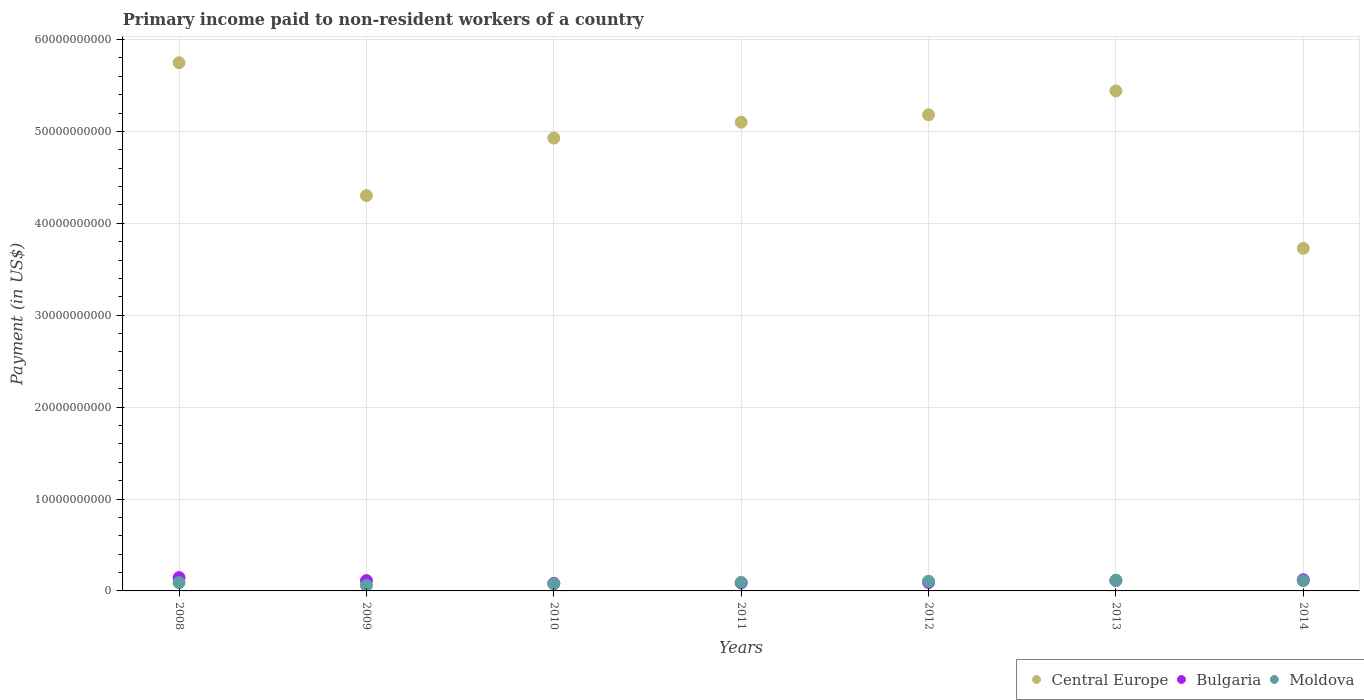How many different coloured dotlines are there?
Your answer should be compact. 3. What is the amount paid to workers in Moldova in 2010?
Offer a very short reply. 7.67e+08. Across all years, what is the maximum amount paid to workers in Moldova?
Your response must be concise. 1.16e+09. Across all years, what is the minimum amount paid to workers in Bulgaria?
Your answer should be very brief. 8.16e+08. In which year was the amount paid to workers in Bulgaria maximum?
Ensure brevity in your answer.  2008. What is the total amount paid to workers in Central Europe in the graph?
Your answer should be very brief. 3.44e+11. What is the difference between the amount paid to workers in Bulgaria in 2011 and that in 2013?
Make the answer very short. -2.82e+08. What is the difference between the amount paid to workers in Central Europe in 2013 and the amount paid to workers in Bulgaria in 2014?
Ensure brevity in your answer.  5.32e+1. What is the average amount paid to workers in Moldova per year?
Offer a terse response. 9.31e+08. In the year 2009, what is the difference between the amount paid to workers in Moldova and amount paid to workers in Central Europe?
Give a very brief answer. -4.24e+1. What is the ratio of the amount paid to workers in Moldova in 2009 to that in 2014?
Your answer should be compact. 0.53. What is the difference between the highest and the second highest amount paid to workers in Moldova?
Your answer should be compact. 4.90e+07. What is the difference between the highest and the lowest amount paid to workers in Bulgaria?
Provide a short and direct response. 6.34e+08. In how many years, is the amount paid to workers in Central Europe greater than the average amount paid to workers in Central Europe taken over all years?
Give a very brief answer. 5. Is the sum of the amount paid to workers in Central Europe in 2009 and 2010 greater than the maximum amount paid to workers in Bulgaria across all years?
Give a very brief answer. Yes. Is it the case that in every year, the sum of the amount paid to workers in Bulgaria and amount paid to workers in Central Europe  is greater than the amount paid to workers in Moldova?
Provide a succinct answer. Yes. Does the amount paid to workers in Bulgaria monotonically increase over the years?
Your response must be concise. No. Is the amount paid to workers in Moldova strictly greater than the amount paid to workers in Central Europe over the years?
Provide a short and direct response. No. How many dotlines are there?
Make the answer very short. 3. What is the difference between two consecutive major ticks on the Y-axis?
Ensure brevity in your answer.  1.00e+1. Does the graph contain any zero values?
Make the answer very short. No. Where does the legend appear in the graph?
Keep it short and to the point. Bottom right. How many legend labels are there?
Provide a short and direct response. 3. What is the title of the graph?
Provide a short and direct response. Primary income paid to non-resident workers of a country. What is the label or title of the Y-axis?
Your answer should be compact. Payment (in US$). What is the Payment (in US$) of Central Europe in 2008?
Offer a terse response. 5.75e+1. What is the Payment (in US$) of Bulgaria in 2008?
Offer a very short reply. 1.45e+09. What is the Payment (in US$) in Moldova in 2008?
Ensure brevity in your answer.  9.06e+08. What is the Payment (in US$) of Central Europe in 2009?
Your answer should be very brief. 4.30e+1. What is the Payment (in US$) in Bulgaria in 2009?
Your response must be concise. 1.12e+09. What is the Payment (in US$) of Moldova in 2009?
Keep it short and to the point. 5.92e+08. What is the Payment (in US$) in Central Europe in 2010?
Keep it short and to the point. 4.93e+1. What is the Payment (in US$) of Bulgaria in 2010?
Your answer should be very brief. 8.16e+08. What is the Payment (in US$) of Moldova in 2010?
Offer a very short reply. 7.67e+08. What is the Payment (in US$) in Central Europe in 2011?
Your answer should be compact. 5.10e+1. What is the Payment (in US$) of Bulgaria in 2011?
Your answer should be very brief. 8.61e+08. What is the Payment (in US$) of Moldova in 2011?
Offer a very short reply. 9.27e+08. What is the Payment (in US$) in Central Europe in 2012?
Provide a short and direct response. 5.18e+1. What is the Payment (in US$) in Bulgaria in 2012?
Offer a very short reply. 9.18e+08. What is the Payment (in US$) in Moldova in 2012?
Make the answer very short. 1.05e+09. What is the Payment (in US$) of Central Europe in 2013?
Your response must be concise. 5.44e+1. What is the Payment (in US$) of Bulgaria in 2013?
Your response must be concise. 1.14e+09. What is the Payment (in US$) of Moldova in 2013?
Offer a terse response. 1.16e+09. What is the Payment (in US$) of Central Europe in 2014?
Your answer should be compact. 3.73e+1. What is the Payment (in US$) of Bulgaria in 2014?
Offer a very short reply. 1.22e+09. What is the Payment (in US$) in Moldova in 2014?
Keep it short and to the point. 1.11e+09. Across all years, what is the maximum Payment (in US$) in Central Europe?
Make the answer very short. 5.75e+1. Across all years, what is the maximum Payment (in US$) of Bulgaria?
Offer a very short reply. 1.45e+09. Across all years, what is the maximum Payment (in US$) of Moldova?
Keep it short and to the point. 1.16e+09. Across all years, what is the minimum Payment (in US$) in Central Europe?
Provide a short and direct response. 3.73e+1. Across all years, what is the minimum Payment (in US$) of Bulgaria?
Your response must be concise. 8.16e+08. Across all years, what is the minimum Payment (in US$) of Moldova?
Give a very brief answer. 5.92e+08. What is the total Payment (in US$) of Central Europe in the graph?
Provide a succinct answer. 3.44e+11. What is the total Payment (in US$) of Bulgaria in the graph?
Make the answer very short. 7.53e+09. What is the total Payment (in US$) of Moldova in the graph?
Give a very brief answer. 6.52e+09. What is the difference between the Payment (in US$) in Central Europe in 2008 and that in 2009?
Give a very brief answer. 1.45e+1. What is the difference between the Payment (in US$) of Bulgaria in 2008 and that in 2009?
Offer a very short reply. 3.31e+08. What is the difference between the Payment (in US$) in Moldova in 2008 and that in 2009?
Your response must be concise. 3.14e+08. What is the difference between the Payment (in US$) of Central Europe in 2008 and that in 2010?
Keep it short and to the point. 8.20e+09. What is the difference between the Payment (in US$) of Bulgaria in 2008 and that in 2010?
Provide a short and direct response. 6.34e+08. What is the difference between the Payment (in US$) of Moldova in 2008 and that in 2010?
Your response must be concise. 1.39e+08. What is the difference between the Payment (in US$) in Central Europe in 2008 and that in 2011?
Your response must be concise. 6.47e+09. What is the difference between the Payment (in US$) of Bulgaria in 2008 and that in 2011?
Make the answer very short. 5.90e+08. What is the difference between the Payment (in US$) in Moldova in 2008 and that in 2011?
Make the answer very short. -2.05e+07. What is the difference between the Payment (in US$) in Central Europe in 2008 and that in 2012?
Make the answer very short. 5.67e+09. What is the difference between the Payment (in US$) of Bulgaria in 2008 and that in 2012?
Offer a terse response. 5.33e+08. What is the difference between the Payment (in US$) of Moldova in 2008 and that in 2012?
Your answer should be very brief. -1.43e+08. What is the difference between the Payment (in US$) in Central Europe in 2008 and that in 2013?
Keep it short and to the point. 3.07e+09. What is the difference between the Payment (in US$) in Bulgaria in 2008 and that in 2013?
Ensure brevity in your answer.  3.09e+08. What is the difference between the Payment (in US$) in Moldova in 2008 and that in 2013?
Offer a very short reply. -2.57e+08. What is the difference between the Payment (in US$) of Central Europe in 2008 and that in 2014?
Your answer should be compact. 2.02e+1. What is the difference between the Payment (in US$) in Bulgaria in 2008 and that in 2014?
Give a very brief answer. 2.27e+08. What is the difference between the Payment (in US$) of Moldova in 2008 and that in 2014?
Your response must be concise. -2.08e+08. What is the difference between the Payment (in US$) in Central Europe in 2009 and that in 2010?
Your answer should be very brief. -6.26e+09. What is the difference between the Payment (in US$) of Bulgaria in 2009 and that in 2010?
Your answer should be compact. 3.03e+08. What is the difference between the Payment (in US$) in Moldova in 2009 and that in 2010?
Ensure brevity in your answer.  -1.75e+08. What is the difference between the Payment (in US$) of Central Europe in 2009 and that in 2011?
Offer a very short reply. -7.99e+09. What is the difference between the Payment (in US$) in Bulgaria in 2009 and that in 2011?
Ensure brevity in your answer.  2.59e+08. What is the difference between the Payment (in US$) in Moldova in 2009 and that in 2011?
Give a very brief answer. -3.35e+08. What is the difference between the Payment (in US$) in Central Europe in 2009 and that in 2012?
Offer a terse response. -8.79e+09. What is the difference between the Payment (in US$) in Bulgaria in 2009 and that in 2012?
Your response must be concise. 2.01e+08. What is the difference between the Payment (in US$) in Moldova in 2009 and that in 2012?
Your response must be concise. -4.57e+08. What is the difference between the Payment (in US$) in Central Europe in 2009 and that in 2013?
Your response must be concise. -1.14e+1. What is the difference between the Payment (in US$) in Bulgaria in 2009 and that in 2013?
Provide a succinct answer. -2.26e+07. What is the difference between the Payment (in US$) of Moldova in 2009 and that in 2013?
Offer a very short reply. -5.71e+08. What is the difference between the Payment (in US$) of Central Europe in 2009 and that in 2014?
Offer a very short reply. 5.74e+09. What is the difference between the Payment (in US$) of Bulgaria in 2009 and that in 2014?
Your answer should be very brief. -1.04e+08. What is the difference between the Payment (in US$) in Moldova in 2009 and that in 2014?
Provide a succinct answer. -5.22e+08. What is the difference between the Payment (in US$) in Central Europe in 2010 and that in 2011?
Your response must be concise. -1.73e+09. What is the difference between the Payment (in US$) of Bulgaria in 2010 and that in 2011?
Ensure brevity in your answer.  -4.41e+07. What is the difference between the Payment (in US$) in Moldova in 2010 and that in 2011?
Give a very brief answer. -1.60e+08. What is the difference between the Payment (in US$) of Central Europe in 2010 and that in 2012?
Keep it short and to the point. -2.54e+09. What is the difference between the Payment (in US$) in Bulgaria in 2010 and that in 2012?
Your response must be concise. -1.02e+08. What is the difference between the Payment (in US$) in Moldova in 2010 and that in 2012?
Ensure brevity in your answer.  -2.82e+08. What is the difference between the Payment (in US$) in Central Europe in 2010 and that in 2013?
Your answer should be very brief. -5.13e+09. What is the difference between the Payment (in US$) in Bulgaria in 2010 and that in 2013?
Offer a terse response. -3.26e+08. What is the difference between the Payment (in US$) of Moldova in 2010 and that in 2013?
Make the answer very short. -3.96e+08. What is the difference between the Payment (in US$) in Central Europe in 2010 and that in 2014?
Offer a terse response. 1.20e+1. What is the difference between the Payment (in US$) of Bulgaria in 2010 and that in 2014?
Offer a very short reply. -4.07e+08. What is the difference between the Payment (in US$) in Moldova in 2010 and that in 2014?
Offer a very short reply. -3.47e+08. What is the difference between the Payment (in US$) of Central Europe in 2011 and that in 2012?
Offer a terse response. -8.04e+08. What is the difference between the Payment (in US$) of Bulgaria in 2011 and that in 2012?
Provide a short and direct response. -5.77e+07. What is the difference between the Payment (in US$) of Moldova in 2011 and that in 2012?
Offer a very short reply. -1.23e+08. What is the difference between the Payment (in US$) of Central Europe in 2011 and that in 2013?
Provide a short and direct response. -3.40e+09. What is the difference between the Payment (in US$) of Bulgaria in 2011 and that in 2013?
Your response must be concise. -2.82e+08. What is the difference between the Payment (in US$) of Moldova in 2011 and that in 2013?
Ensure brevity in your answer.  -2.37e+08. What is the difference between the Payment (in US$) of Central Europe in 2011 and that in 2014?
Ensure brevity in your answer.  1.37e+1. What is the difference between the Payment (in US$) in Bulgaria in 2011 and that in 2014?
Ensure brevity in your answer.  -3.63e+08. What is the difference between the Payment (in US$) of Moldova in 2011 and that in 2014?
Provide a succinct answer. -1.88e+08. What is the difference between the Payment (in US$) of Central Europe in 2012 and that in 2013?
Your answer should be compact. -2.59e+09. What is the difference between the Payment (in US$) of Bulgaria in 2012 and that in 2013?
Keep it short and to the point. -2.24e+08. What is the difference between the Payment (in US$) of Moldova in 2012 and that in 2013?
Make the answer very short. -1.14e+08. What is the difference between the Payment (in US$) in Central Europe in 2012 and that in 2014?
Offer a very short reply. 1.45e+1. What is the difference between the Payment (in US$) of Bulgaria in 2012 and that in 2014?
Provide a succinct answer. -3.05e+08. What is the difference between the Payment (in US$) of Moldova in 2012 and that in 2014?
Your response must be concise. -6.50e+07. What is the difference between the Payment (in US$) of Central Europe in 2013 and that in 2014?
Provide a short and direct response. 1.71e+1. What is the difference between the Payment (in US$) of Bulgaria in 2013 and that in 2014?
Your answer should be compact. -8.15e+07. What is the difference between the Payment (in US$) of Moldova in 2013 and that in 2014?
Provide a succinct answer. 4.90e+07. What is the difference between the Payment (in US$) of Central Europe in 2008 and the Payment (in US$) of Bulgaria in 2009?
Provide a succinct answer. 5.64e+1. What is the difference between the Payment (in US$) in Central Europe in 2008 and the Payment (in US$) in Moldova in 2009?
Ensure brevity in your answer.  5.69e+1. What is the difference between the Payment (in US$) of Bulgaria in 2008 and the Payment (in US$) of Moldova in 2009?
Offer a terse response. 8.59e+08. What is the difference between the Payment (in US$) of Central Europe in 2008 and the Payment (in US$) of Bulgaria in 2010?
Make the answer very short. 5.67e+1. What is the difference between the Payment (in US$) of Central Europe in 2008 and the Payment (in US$) of Moldova in 2010?
Ensure brevity in your answer.  5.67e+1. What is the difference between the Payment (in US$) of Bulgaria in 2008 and the Payment (in US$) of Moldova in 2010?
Ensure brevity in your answer.  6.84e+08. What is the difference between the Payment (in US$) of Central Europe in 2008 and the Payment (in US$) of Bulgaria in 2011?
Offer a terse response. 5.66e+1. What is the difference between the Payment (in US$) of Central Europe in 2008 and the Payment (in US$) of Moldova in 2011?
Ensure brevity in your answer.  5.66e+1. What is the difference between the Payment (in US$) of Bulgaria in 2008 and the Payment (in US$) of Moldova in 2011?
Your response must be concise. 5.24e+08. What is the difference between the Payment (in US$) of Central Europe in 2008 and the Payment (in US$) of Bulgaria in 2012?
Provide a short and direct response. 5.66e+1. What is the difference between the Payment (in US$) of Central Europe in 2008 and the Payment (in US$) of Moldova in 2012?
Give a very brief answer. 5.64e+1. What is the difference between the Payment (in US$) in Bulgaria in 2008 and the Payment (in US$) in Moldova in 2012?
Your answer should be compact. 4.02e+08. What is the difference between the Payment (in US$) in Central Europe in 2008 and the Payment (in US$) in Bulgaria in 2013?
Your response must be concise. 5.63e+1. What is the difference between the Payment (in US$) of Central Europe in 2008 and the Payment (in US$) of Moldova in 2013?
Give a very brief answer. 5.63e+1. What is the difference between the Payment (in US$) of Bulgaria in 2008 and the Payment (in US$) of Moldova in 2013?
Give a very brief answer. 2.88e+08. What is the difference between the Payment (in US$) in Central Europe in 2008 and the Payment (in US$) in Bulgaria in 2014?
Give a very brief answer. 5.63e+1. What is the difference between the Payment (in US$) in Central Europe in 2008 and the Payment (in US$) in Moldova in 2014?
Give a very brief answer. 5.64e+1. What is the difference between the Payment (in US$) in Bulgaria in 2008 and the Payment (in US$) in Moldova in 2014?
Keep it short and to the point. 3.36e+08. What is the difference between the Payment (in US$) in Central Europe in 2009 and the Payment (in US$) in Bulgaria in 2010?
Provide a short and direct response. 4.22e+1. What is the difference between the Payment (in US$) of Central Europe in 2009 and the Payment (in US$) of Moldova in 2010?
Offer a terse response. 4.23e+1. What is the difference between the Payment (in US$) in Bulgaria in 2009 and the Payment (in US$) in Moldova in 2010?
Provide a succinct answer. 3.53e+08. What is the difference between the Payment (in US$) of Central Europe in 2009 and the Payment (in US$) of Bulgaria in 2011?
Give a very brief answer. 4.22e+1. What is the difference between the Payment (in US$) of Central Europe in 2009 and the Payment (in US$) of Moldova in 2011?
Provide a succinct answer. 4.21e+1. What is the difference between the Payment (in US$) of Bulgaria in 2009 and the Payment (in US$) of Moldova in 2011?
Ensure brevity in your answer.  1.93e+08. What is the difference between the Payment (in US$) of Central Europe in 2009 and the Payment (in US$) of Bulgaria in 2012?
Keep it short and to the point. 4.21e+1. What is the difference between the Payment (in US$) of Central Europe in 2009 and the Payment (in US$) of Moldova in 2012?
Make the answer very short. 4.20e+1. What is the difference between the Payment (in US$) of Bulgaria in 2009 and the Payment (in US$) of Moldova in 2012?
Provide a succinct answer. 7.02e+07. What is the difference between the Payment (in US$) of Central Europe in 2009 and the Payment (in US$) of Bulgaria in 2013?
Make the answer very short. 4.19e+1. What is the difference between the Payment (in US$) of Central Europe in 2009 and the Payment (in US$) of Moldova in 2013?
Ensure brevity in your answer.  4.19e+1. What is the difference between the Payment (in US$) of Bulgaria in 2009 and the Payment (in US$) of Moldova in 2013?
Provide a succinct answer. -4.38e+07. What is the difference between the Payment (in US$) in Central Europe in 2009 and the Payment (in US$) in Bulgaria in 2014?
Keep it short and to the point. 4.18e+1. What is the difference between the Payment (in US$) in Central Europe in 2009 and the Payment (in US$) in Moldova in 2014?
Provide a succinct answer. 4.19e+1. What is the difference between the Payment (in US$) of Bulgaria in 2009 and the Payment (in US$) of Moldova in 2014?
Your answer should be very brief. 5.14e+06. What is the difference between the Payment (in US$) in Central Europe in 2010 and the Payment (in US$) in Bulgaria in 2011?
Ensure brevity in your answer.  4.84e+1. What is the difference between the Payment (in US$) in Central Europe in 2010 and the Payment (in US$) in Moldova in 2011?
Make the answer very short. 4.84e+1. What is the difference between the Payment (in US$) in Bulgaria in 2010 and the Payment (in US$) in Moldova in 2011?
Provide a short and direct response. -1.10e+08. What is the difference between the Payment (in US$) of Central Europe in 2010 and the Payment (in US$) of Bulgaria in 2012?
Your answer should be very brief. 4.84e+1. What is the difference between the Payment (in US$) of Central Europe in 2010 and the Payment (in US$) of Moldova in 2012?
Provide a short and direct response. 4.82e+1. What is the difference between the Payment (in US$) in Bulgaria in 2010 and the Payment (in US$) in Moldova in 2012?
Your answer should be very brief. -2.33e+08. What is the difference between the Payment (in US$) of Central Europe in 2010 and the Payment (in US$) of Bulgaria in 2013?
Offer a terse response. 4.81e+1. What is the difference between the Payment (in US$) of Central Europe in 2010 and the Payment (in US$) of Moldova in 2013?
Make the answer very short. 4.81e+1. What is the difference between the Payment (in US$) in Bulgaria in 2010 and the Payment (in US$) in Moldova in 2013?
Make the answer very short. -3.47e+08. What is the difference between the Payment (in US$) of Central Europe in 2010 and the Payment (in US$) of Bulgaria in 2014?
Offer a terse response. 4.81e+1. What is the difference between the Payment (in US$) in Central Europe in 2010 and the Payment (in US$) in Moldova in 2014?
Offer a terse response. 4.82e+1. What is the difference between the Payment (in US$) of Bulgaria in 2010 and the Payment (in US$) of Moldova in 2014?
Offer a very short reply. -2.98e+08. What is the difference between the Payment (in US$) of Central Europe in 2011 and the Payment (in US$) of Bulgaria in 2012?
Keep it short and to the point. 5.01e+1. What is the difference between the Payment (in US$) in Central Europe in 2011 and the Payment (in US$) in Moldova in 2012?
Your answer should be very brief. 5.00e+1. What is the difference between the Payment (in US$) of Bulgaria in 2011 and the Payment (in US$) of Moldova in 2012?
Give a very brief answer. -1.89e+08. What is the difference between the Payment (in US$) of Central Europe in 2011 and the Payment (in US$) of Bulgaria in 2013?
Ensure brevity in your answer.  4.99e+1. What is the difference between the Payment (in US$) of Central Europe in 2011 and the Payment (in US$) of Moldova in 2013?
Give a very brief answer. 4.98e+1. What is the difference between the Payment (in US$) in Bulgaria in 2011 and the Payment (in US$) in Moldova in 2013?
Your response must be concise. -3.03e+08. What is the difference between the Payment (in US$) of Central Europe in 2011 and the Payment (in US$) of Bulgaria in 2014?
Make the answer very short. 4.98e+1. What is the difference between the Payment (in US$) of Central Europe in 2011 and the Payment (in US$) of Moldova in 2014?
Your answer should be compact. 4.99e+1. What is the difference between the Payment (in US$) in Bulgaria in 2011 and the Payment (in US$) in Moldova in 2014?
Your answer should be compact. -2.54e+08. What is the difference between the Payment (in US$) in Central Europe in 2012 and the Payment (in US$) in Bulgaria in 2013?
Your answer should be compact. 5.07e+1. What is the difference between the Payment (in US$) of Central Europe in 2012 and the Payment (in US$) of Moldova in 2013?
Give a very brief answer. 5.06e+1. What is the difference between the Payment (in US$) of Bulgaria in 2012 and the Payment (in US$) of Moldova in 2013?
Offer a terse response. -2.45e+08. What is the difference between the Payment (in US$) in Central Europe in 2012 and the Payment (in US$) in Bulgaria in 2014?
Your answer should be very brief. 5.06e+1. What is the difference between the Payment (in US$) in Central Europe in 2012 and the Payment (in US$) in Moldova in 2014?
Your answer should be compact. 5.07e+1. What is the difference between the Payment (in US$) in Bulgaria in 2012 and the Payment (in US$) in Moldova in 2014?
Offer a very short reply. -1.96e+08. What is the difference between the Payment (in US$) in Central Europe in 2013 and the Payment (in US$) in Bulgaria in 2014?
Ensure brevity in your answer.  5.32e+1. What is the difference between the Payment (in US$) in Central Europe in 2013 and the Payment (in US$) in Moldova in 2014?
Your answer should be compact. 5.33e+1. What is the difference between the Payment (in US$) in Bulgaria in 2013 and the Payment (in US$) in Moldova in 2014?
Keep it short and to the point. 2.77e+07. What is the average Payment (in US$) of Central Europe per year?
Give a very brief answer. 4.92e+1. What is the average Payment (in US$) of Bulgaria per year?
Provide a short and direct response. 1.08e+09. What is the average Payment (in US$) in Moldova per year?
Give a very brief answer. 9.31e+08. In the year 2008, what is the difference between the Payment (in US$) of Central Europe and Payment (in US$) of Bulgaria?
Your answer should be compact. 5.60e+1. In the year 2008, what is the difference between the Payment (in US$) of Central Europe and Payment (in US$) of Moldova?
Provide a succinct answer. 5.66e+1. In the year 2008, what is the difference between the Payment (in US$) of Bulgaria and Payment (in US$) of Moldova?
Your answer should be compact. 5.45e+08. In the year 2009, what is the difference between the Payment (in US$) in Central Europe and Payment (in US$) in Bulgaria?
Your answer should be very brief. 4.19e+1. In the year 2009, what is the difference between the Payment (in US$) of Central Europe and Payment (in US$) of Moldova?
Your response must be concise. 4.24e+1. In the year 2009, what is the difference between the Payment (in US$) in Bulgaria and Payment (in US$) in Moldova?
Provide a short and direct response. 5.27e+08. In the year 2010, what is the difference between the Payment (in US$) in Central Europe and Payment (in US$) in Bulgaria?
Provide a succinct answer. 4.85e+1. In the year 2010, what is the difference between the Payment (in US$) in Central Europe and Payment (in US$) in Moldova?
Your answer should be very brief. 4.85e+1. In the year 2010, what is the difference between the Payment (in US$) of Bulgaria and Payment (in US$) of Moldova?
Give a very brief answer. 4.94e+07. In the year 2011, what is the difference between the Payment (in US$) of Central Europe and Payment (in US$) of Bulgaria?
Offer a very short reply. 5.01e+1. In the year 2011, what is the difference between the Payment (in US$) in Central Europe and Payment (in US$) in Moldova?
Your response must be concise. 5.01e+1. In the year 2011, what is the difference between the Payment (in US$) of Bulgaria and Payment (in US$) of Moldova?
Keep it short and to the point. -6.62e+07. In the year 2012, what is the difference between the Payment (in US$) in Central Europe and Payment (in US$) in Bulgaria?
Offer a terse response. 5.09e+1. In the year 2012, what is the difference between the Payment (in US$) of Central Europe and Payment (in US$) of Moldova?
Your response must be concise. 5.08e+1. In the year 2012, what is the difference between the Payment (in US$) of Bulgaria and Payment (in US$) of Moldova?
Keep it short and to the point. -1.31e+08. In the year 2013, what is the difference between the Payment (in US$) of Central Europe and Payment (in US$) of Bulgaria?
Provide a succinct answer. 5.33e+1. In the year 2013, what is the difference between the Payment (in US$) in Central Europe and Payment (in US$) in Moldova?
Give a very brief answer. 5.32e+1. In the year 2013, what is the difference between the Payment (in US$) in Bulgaria and Payment (in US$) in Moldova?
Provide a succinct answer. -2.12e+07. In the year 2014, what is the difference between the Payment (in US$) in Central Europe and Payment (in US$) in Bulgaria?
Give a very brief answer. 3.61e+1. In the year 2014, what is the difference between the Payment (in US$) in Central Europe and Payment (in US$) in Moldova?
Make the answer very short. 3.62e+1. In the year 2014, what is the difference between the Payment (in US$) in Bulgaria and Payment (in US$) in Moldova?
Keep it short and to the point. 1.09e+08. What is the ratio of the Payment (in US$) in Central Europe in 2008 to that in 2009?
Your answer should be very brief. 1.34. What is the ratio of the Payment (in US$) of Bulgaria in 2008 to that in 2009?
Keep it short and to the point. 1.3. What is the ratio of the Payment (in US$) in Moldova in 2008 to that in 2009?
Ensure brevity in your answer.  1.53. What is the ratio of the Payment (in US$) of Central Europe in 2008 to that in 2010?
Give a very brief answer. 1.17. What is the ratio of the Payment (in US$) of Bulgaria in 2008 to that in 2010?
Offer a very short reply. 1.78. What is the ratio of the Payment (in US$) in Moldova in 2008 to that in 2010?
Offer a very short reply. 1.18. What is the ratio of the Payment (in US$) in Central Europe in 2008 to that in 2011?
Your answer should be compact. 1.13. What is the ratio of the Payment (in US$) of Bulgaria in 2008 to that in 2011?
Ensure brevity in your answer.  1.69. What is the ratio of the Payment (in US$) in Moldova in 2008 to that in 2011?
Your response must be concise. 0.98. What is the ratio of the Payment (in US$) of Central Europe in 2008 to that in 2012?
Your response must be concise. 1.11. What is the ratio of the Payment (in US$) of Bulgaria in 2008 to that in 2012?
Your answer should be compact. 1.58. What is the ratio of the Payment (in US$) in Moldova in 2008 to that in 2012?
Your response must be concise. 0.86. What is the ratio of the Payment (in US$) in Central Europe in 2008 to that in 2013?
Your answer should be compact. 1.06. What is the ratio of the Payment (in US$) in Bulgaria in 2008 to that in 2013?
Offer a very short reply. 1.27. What is the ratio of the Payment (in US$) in Moldova in 2008 to that in 2013?
Make the answer very short. 0.78. What is the ratio of the Payment (in US$) in Central Europe in 2008 to that in 2014?
Offer a very short reply. 1.54. What is the ratio of the Payment (in US$) in Bulgaria in 2008 to that in 2014?
Offer a very short reply. 1.19. What is the ratio of the Payment (in US$) in Moldova in 2008 to that in 2014?
Keep it short and to the point. 0.81. What is the ratio of the Payment (in US$) of Central Europe in 2009 to that in 2010?
Keep it short and to the point. 0.87. What is the ratio of the Payment (in US$) of Bulgaria in 2009 to that in 2010?
Give a very brief answer. 1.37. What is the ratio of the Payment (in US$) of Moldova in 2009 to that in 2010?
Keep it short and to the point. 0.77. What is the ratio of the Payment (in US$) in Central Europe in 2009 to that in 2011?
Your answer should be compact. 0.84. What is the ratio of the Payment (in US$) of Bulgaria in 2009 to that in 2011?
Keep it short and to the point. 1.3. What is the ratio of the Payment (in US$) of Moldova in 2009 to that in 2011?
Keep it short and to the point. 0.64. What is the ratio of the Payment (in US$) in Central Europe in 2009 to that in 2012?
Provide a succinct answer. 0.83. What is the ratio of the Payment (in US$) of Bulgaria in 2009 to that in 2012?
Your answer should be compact. 1.22. What is the ratio of the Payment (in US$) in Moldova in 2009 to that in 2012?
Provide a succinct answer. 0.56. What is the ratio of the Payment (in US$) in Central Europe in 2009 to that in 2013?
Give a very brief answer. 0.79. What is the ratio of the Payment (in US$) in Bulgaria in 2009 to that in 2013?
Your response must be concise. 0.98. What is the ratio of the Payment (in US$) in Moldova in 2009 to that in 2013?
Make the answer very short. 0.51. What is the ratio of the Payment (in US$) in Central Europe in 2009 to that in 2014?
Your answer should be very brief. 1.15. What is the ratio of the Payment (in US$) in Bulgaria in 2009 to that in 2014?
Offer a very short reply. 0.92. What is the ratio of the Payment (in US$) of Moldova in 2009 to that in 2014?
Offer a terse response. 0.53. What is the ratio of the Payment (in US$) of Central Europe in 2010 to that in 2011?
Ensure brevity in your answer.  0.97. What is the ratio of the Payment (in US$) of Bulgaria in 2010 to that in 2011?
Provide a succinct answer. 0.95. What is the ratio of the Payment (in US$) in Moldova in 2010 to that in 2011?
Provide a succinct answer. 0.83. What is the ratio of the Payment (in US$) of Central Europe in 2010 to that in 2012?
Your answer should be compact. 0.95. What is the ratio of the Payment (in US$) in Bulgaria in 2010 to that in 2012?
Make the answer very short. 0.89. What is the ratio of the Payment (in US$) in Moldova in 2010 to that in 2012?
Provide a short and direct response. 0.73. What is the ratio of the Payment (in US$) of Central Europe in 2010 to that in 2013?
Your answer should be compact. 0.91. What is the ratio of the Payment (in US$) of Bulgaria in 2010 to that in 2013?
Offer a very short reply. 0.71. What is the ratio of the Payment (in US$) in Moldova in 2010 to that in 2013?
Provide a succinct answer. 0.66. What is the ratio of the Payment (in US$) of Central Europe in 2010 to that in 2014?
Your answer should be very brief. 1.32. What is the ratio of the Payment (in US$) of Bulgaria in 2010 to that in 2014?
Provide a succinct answer. 0.67. What is the ratio of the Payment (in US$) in Moldova in 2010 to that in 2014?
Ensure brevity in your answer.  0.69. What is the ratio of the Payment (in US$) in Central Europe in 2011 to that in 2012?
Offer a terse response. 0.98. What is the ratio of the Payment (in US$) in Bulgaria in 2011 to that in 2012?
Give a very brief answer. 0.94. What is the ratio of the Payment (in US$) of Moldova in 2011 to that in 2012?
Keep it short and to the point. 0.88. What is the ratio of the Payment (in US$) of Central Europe in 2011 to that in 2013?
Provide a succinct answer. 0.94. What is the ratio of the Payment (in US$) of Bulgaria in 2011 to that in 2013?
Give a very brief answer. 0.75. What is the ratio of the Payment (in US$) of Moldova in 2011 to that in 2013?
Your answer should be compact. 0.8. What is the ratio of the Payment (in US$) of Central Europe in 2011 to that in 2014?
Provide a succinct answer. 1.37. What is the ratio of the Payment (in US$) of Bulgaria in 2011 to that in 2014?
Provide a succinct answer. 0.7. What is the ratio of the Payment (in US$) of Moldova in 2011 to that in 2014?
Give a very brief answer. 0.83. What is the ratio of the Payment (in US$) in Central Europe in 2012 to that in 2013?
Give a very brief answer. 0.95. What is the ratio of the Payment (in US$) in Bulgaria in 2012 to that in 2013?
Give a very brief answer. 0.8. What is the ratio of the Payment (in US$) of Moldova in 2012 to that in 2013?
Ensure brevity in your answer.  0.9. What is the ratio of the Payment (in US$) of Central Europe in 2012 to that in 2014?
Your response must be concise. 1.39. What is the ratio of the Payment (in US$) in Bulgaria in 2012 to that in 2014?
Give a very brief answer. 0.75. What is the ratio of the Payment (in US$) of Moldova in 2012 to that in 2014?
Keep it short and to the point. 0.94. What is the ratio of the Payment (in US$) of Central Europe in 2013 to that in 2014?
Your response must be concise. 1.46. What is the ratio of the Payment (in US$) in Bulgaria in 2013 to that in 2014?
Your answer should be compact. 0.93. What is the ratio of the Payment (in US$) in Moldova in 2013 to that in 2014?
Offer a terse response. 1.04. What is the difference between the highest and the second highest Payment (in US$) in Central Europe?
Make the answer very short. 3.07e+09. What is the difference between the highest and the second highest Payment (in US$) in Bulgaria?
Your response must be concise. 2.27e+08. What is the difference between the highest and the second highest Payment (in US$) of Moldova?
Your answer should be very brief. 4.90e+07. What is the difference between the highest and the lowest Payment (in US$) of Central Europe?
Your response must be concise. 2.02e+1. What is the difference between the highest and the lowest Payment (in US$) of Bulgaria?
Provide a short and direct response. 6.34e+08. What is the difference between the highest and the lowest Payment (in US$) of Moldova?
Provide a short and direct response. 5.71e+08. 